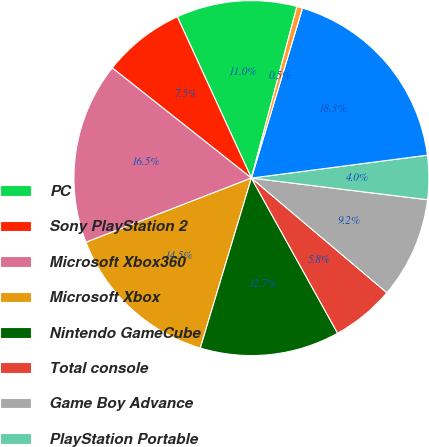Convert chart. <chart><loc_0><loc_0><loc_500><loc_500><pie_chart><fcel>PC<fcel>Sony PlayStation 2<fcel>Microsoft Xbox360<fcel>Microsoft Xbox<fcel>Nintendo GameCube<fcel>Total console<fcel>Game Boy Advance<fcel>PlayStation Portable<fcel>Nintendo Dual Screen<fcel>Total hand-held<nl><fcel>10.98%<fcel>7.49%<fcel>16.55%<fcel>14.46%<fcel>12.72%<fcel>5.75%<fcel>9.23%<fcel>4.01%<fcel>18.29%<fcel>0.52%<nl></chart> 